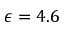Convert formula to latex. <formula><loc_0><loc_0><loc_500><loc_500>\epsilon = 4 . 6</formula> 